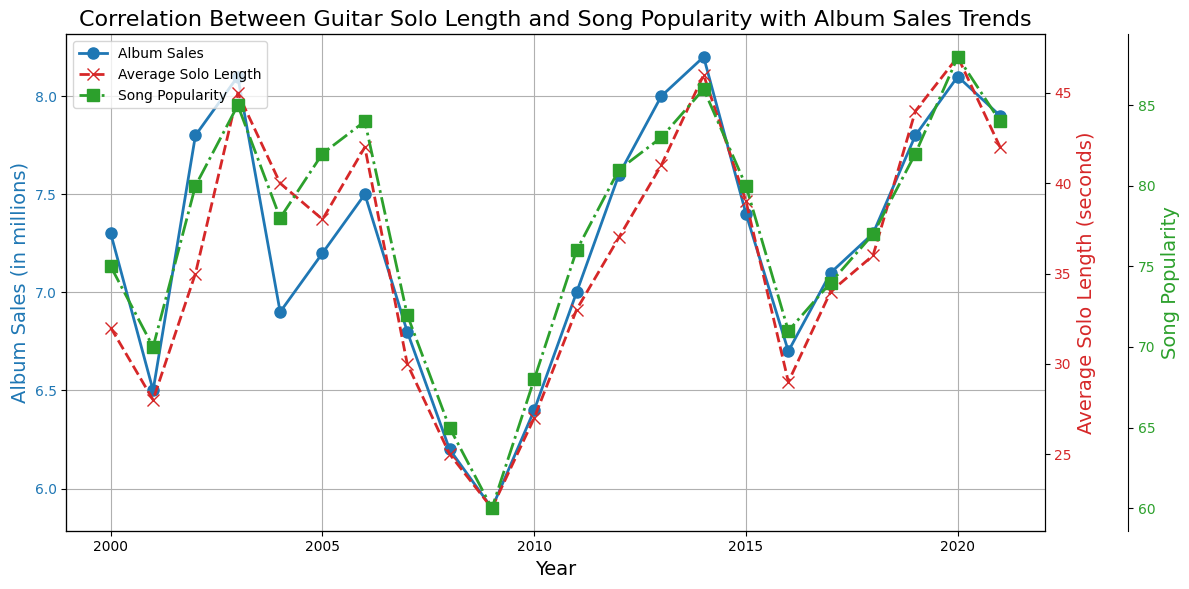Which year had the highest album sales? Look at the blue line representing album sales and identify the highest point. The plot shows the year 2014 had the highest album sales with 8.2 million.
Answer: 2014 Which year had the longest average solo length? Check the red line with x markers, which represents the average solo length. The longest average solo length is in 2020 with 47 seconds.
Answer: 2020 Compare the song popularity in 2003 and 2019. Which year had a higher popularity? Look at the green line with square markers, representing song popularity. In 2003, song popularity is 85, and in 2019 it is 82. Therefore, 2003 had a higher popularity.
Answer: 2003 What is the difference in album sales between 2012 and 2021? Review the album sales data for both years from the blue line. In 2012, sales are 7.6 million, and in 2021 they are 7.9 million. The difference is 7.9 - 7.6 = 0.3 million.
Answer: 0.3 million What trend can you observe in the average solo length from 2008 to 2010? Examine the red line from 2008 to 2010. The average solo length increases from 25 seconds in 2008 to 27 seconds in 2010.
Answer: Increasing When did the song popularity reach its lowest point? Locate the lowest point on the green line. The lowest song popularity is in 2009, with a popularity score of 60.
Answer: 2009 Is there generally a correlation between average solo length and song popularity? Observe the overall trends of the red and green lines. Both lines tend to increase over time, suggesting a positive correlation between longer solos and higher song popularity.
Answer: Yes, positive correlation During which years did the album sales not exceed 7 million? Review the album sales data on the blue line. The years where album sales did not exceed 7 million are 2008, 2009, 2010, 2016, and 2017.
Answer: 2008, 2009, 2010, 2016, 2017 By how much did the average solo length increase from 2000 to 2020? Check the average solo length for these years on the red line. In 2000, the length was 32 seconds, and in 2020 it was 47 seconds. The increase is 47 - 32 = 15 seconds.
Answer: 15 seconds What relationship can you infer between album sales and song popularity in 2014? Consider the values for 2014. Album sales are at their peak (8.2 million), and song popularity is also very high (86). Hence, high album sales correlate with high song popularity.
Answer: High album sales correlate with high song popularity 